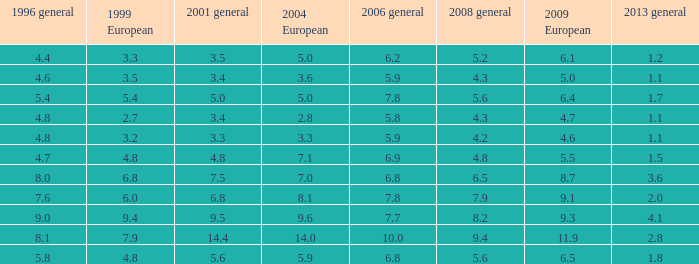What is the peak value for general 2008 when there is under None. 